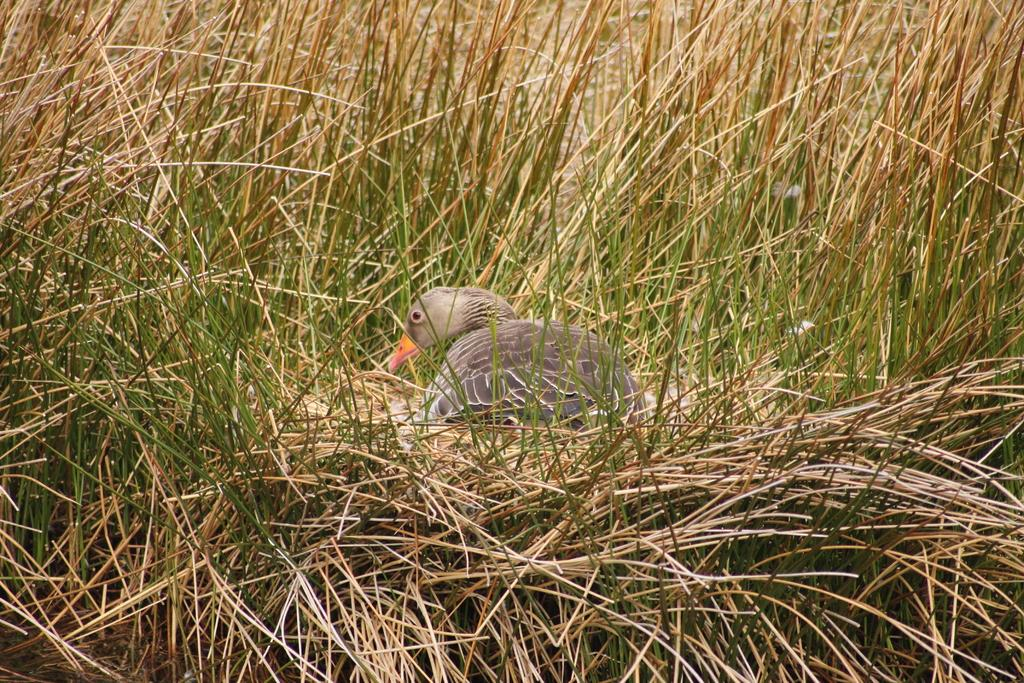What type of animal can be seen in the image? There is a bird in the image. Where is the bird located in the image? The bird is resting on the grass. What type of invention is being demonstrated by the bird in the image? There is no invention being demonstrated by the bird in the image; it is simply resting on the grass. 